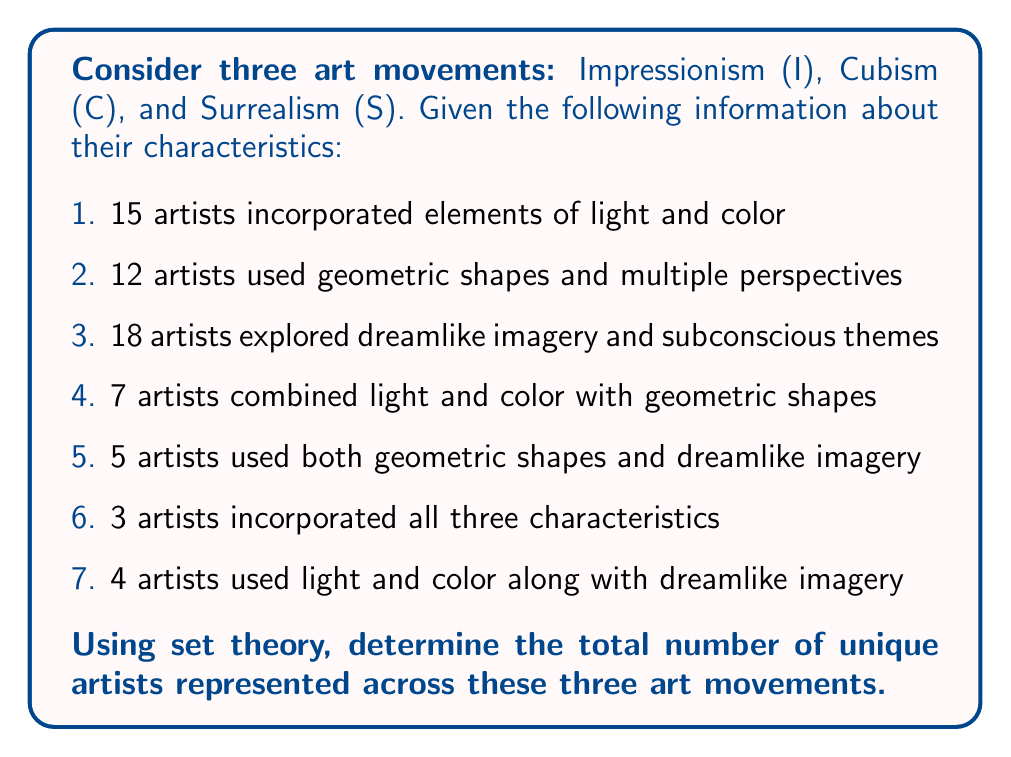Can you answer this question? To solve this problem, we'll use the principle of inclusion-exclusion from set theory. Let's break it down step-by-step:

1. Define our sets:
   I = artists using Impressionist techniques (light and color)
   C = artists using Cubist techniques (geometric shapes and multiple perspectives)
   S = artists using Surrealist techniques (dreamlike imagery and subconscious themes)

2. Given information in set notation:
   $|I| = 15$, $|C| = 12$, $|S| = 18$
   $|I \cap C| = 7$, $|C \cap S| = 5$, $|I \cap S| = 4$
   $|I \cap C \cap S| = 3$

3. The principle of inclusion-exclusion for three sets is:
   $$|I \cup C \cup S| = |I| + |C| + |S| - |I \cap C| - |I \cap S| - |C \cap S| + |I \cap C \cap S|$$

4. Substituting the values:
   $$|I \cup C \cup S| = 15 + 12 + 18 - 7 - 4 - 5 + 3$$

5. Calculating:
   $$|I \cup C \cup S| = 45 - 16 + 3 = 32$$

Therefore, the total number of unique artists represented across these three art movements is 32.
Answer: 32 unique artists 